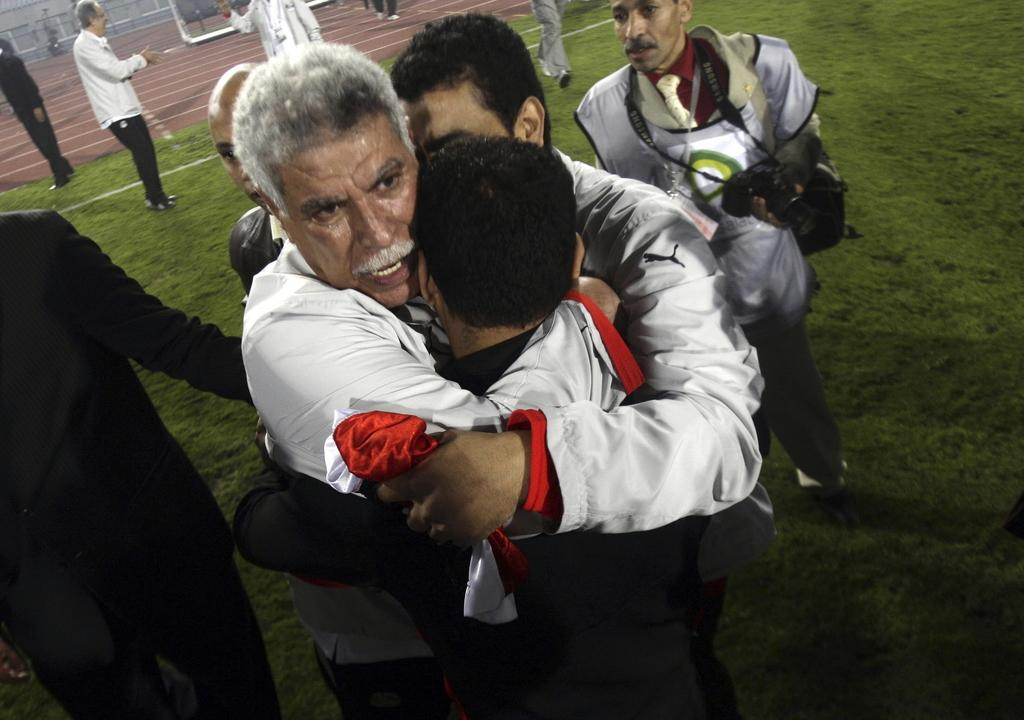What is the main subject of the image? The main subject of the image is a group of people. Where are some of the people located in the image? Some people are standing on the grass. What are some of the people doing in the image? Some people are walking. What can be seen in the background of the image? There are metal rods in the background of the image. What type of legal advice is the lawyer providing in the image? There is no lawyer present in the image, so it is not possible to determine what legal advice might be provided. 